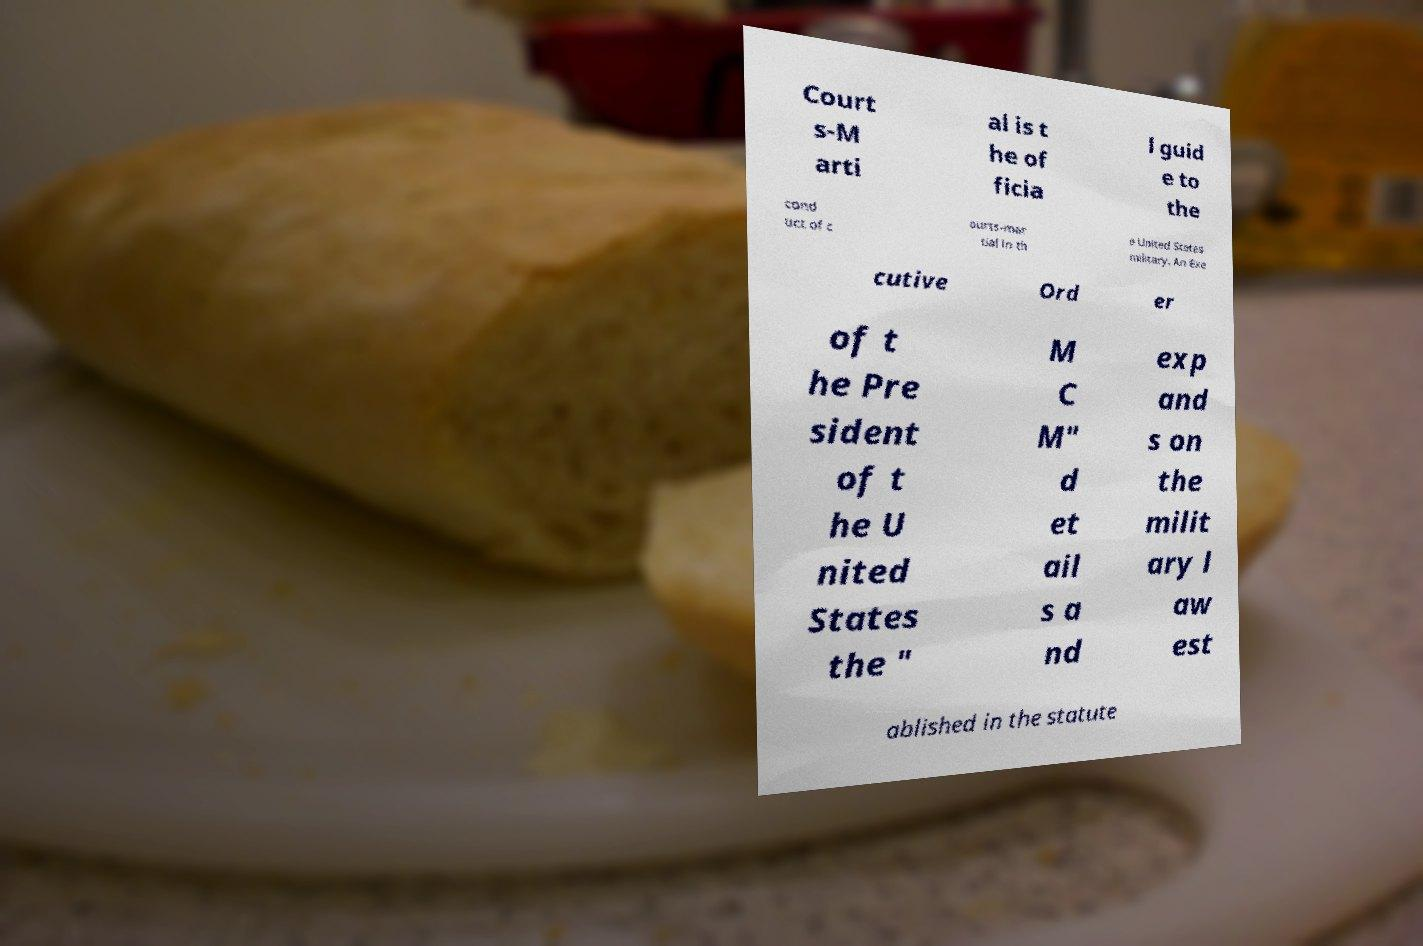Could you assist in decoding the text presented in this image and type it out clearly? Court s-M arti al is t he of ficia l guid e to the cond uct of c ourts-mar tial in th e United States military. An Exe cutive Ord er of t he Pre sident of t he U nited States the " M C M" d et ail s a nd exp and s on the milit ary l aw est ablished in the statute 